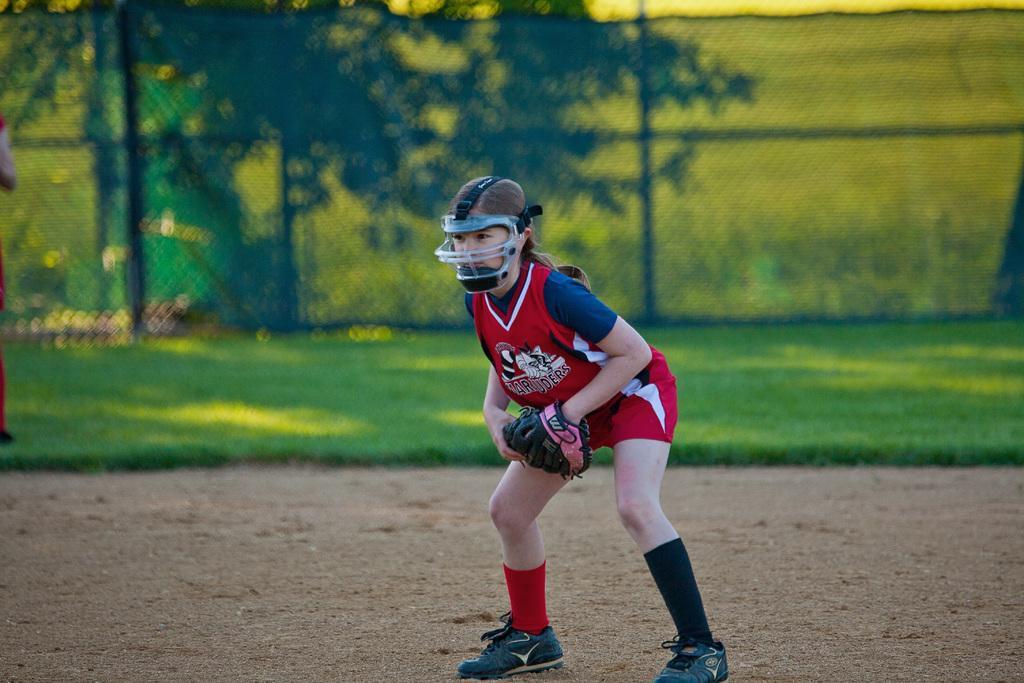Describe this image in one or two sentences. In the foreground of this image, there is a woman standing, wearing gloves, helmet and shoes on the ground. In the background, there is greenery and the fencing. 